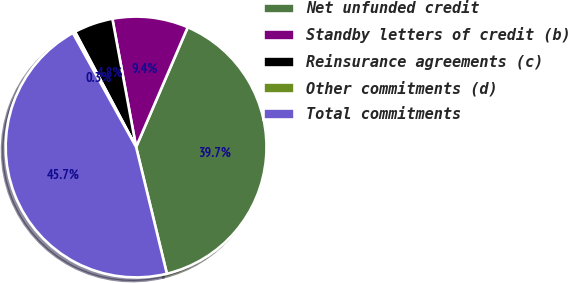<chart> <loc_0><loc_0><loc_500><loc_500><pie_chart><fcel>Net unfunded credit<fcel>Standby letters of credit (b)<fcel>Reinsurance agreements (c)<fcel>Other commitments (d)<fcel>Total commitments<nl><fcel>39.73%<fcel>9.39%<fcel>4.85%<fcel>0.3%<fcel>45.73%<nl></chart> 